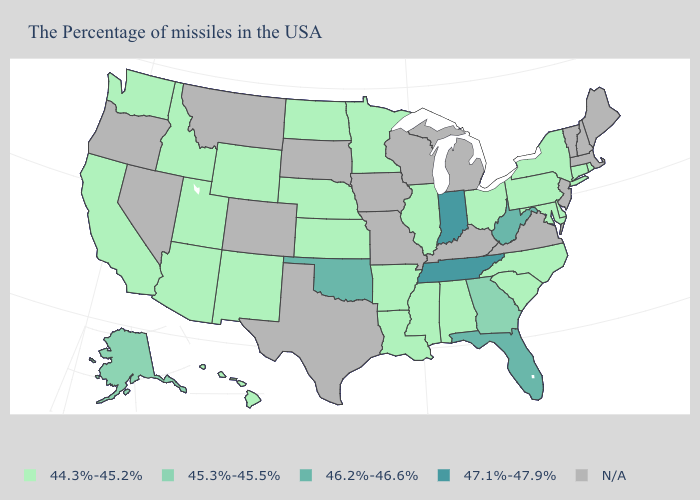Which states have the highest value in the USA?
Short answer required. Indiana, Tennessee. Is the legend a continuous bar?
Give a very brief answer. No. What is the lowest value in the USA?
Concise answer only. 44.3%-45.2%. Which states have the highest value in the USA?
Write a very short answer. Indiana, Tennessee. What is the highest value in states that border West Virginia?
Answer briefly. 44.3%-45.2%. Is the legend a continuous bar?
Answer briefly. No. Does the first symbol in the legend represent the smallest category?
Quick response, please. Yes. What is the lowest value in the USA?
Write a very short answer. 44.3%-45.2%. What is the value of Oklahoma?
Concise answer only. 46.2%-46.6%. What is the highest value in the South ?
Keep it brief. 47.1%-47.9%. Does Delaware have the highest value in the South?
Short answer required. No. What is the highest value in the USA?
Concise answer only. 47.1%-47.9%. Name the states that have a value in the range 47.1%-47.9%?
Answer briefly. Indiana, Tennessee. Which states have the lowest value in the USA?
Keep it brief. Rhode Island, Connecticut, New York, Delaware, Maryland, Pennsylvania, North Carolina, South Carolina, Ohio, Alabama, Illinois, Mississippi, Louisiana, Arkansas, Minnesota, Kansas, Nebraska, North Dakota, Wyoming, New Mexico, Utah, Arizona, Idaho, California, Washington, Hawaii. What is the value of Utah?
Short answer required. 44.3%-45.2%. 